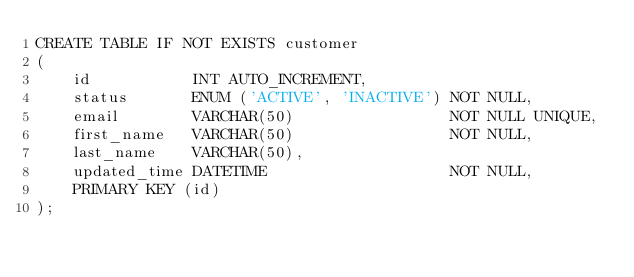Convert code to text. <code><loc_0><loc_0><loc_500><loc_500><_SQL_>CREATE TABLE IF NOT EXISTS customer
(
    id           INT AUTO_INCREMENT,
    status       ENUM ('ACTIVE', 'INACTIVE') NOT NULL,
    email        VARCHAR(50)                 NOT NULL UNIQUE,
    first_name   VARCHAR(50)                 NOT NULL,
    last_name    VARCHAR(50),
    updated_time DATETIME                    NOT NULL,
    PRIMARY KEY (id)
);
</code> 